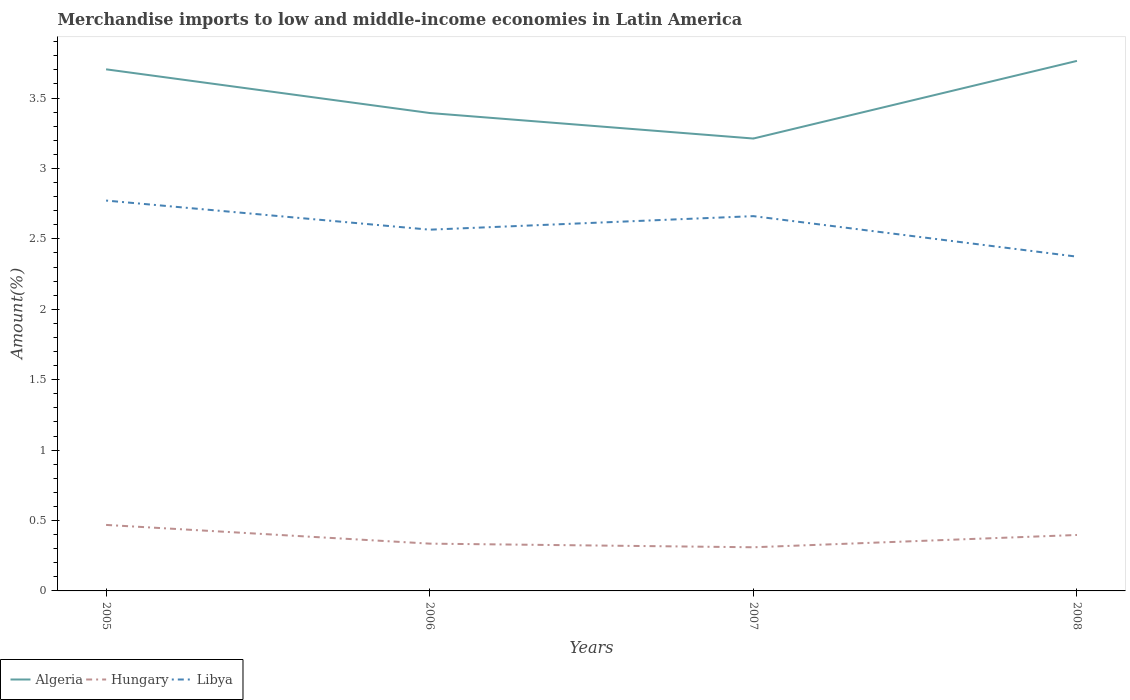How many different coloured lines are there?
Offer a terse response. 3. Is the number of lines equal to the number of legend labels?
Offer a very short reply. Yes. Across all years, what is the maximum percentage of amount earned from merchandise imports in Hungary?
Your answer should be very brief. 0.31. In which year was the percentage of amount earned from merchandise imports in Algeria maximum?
Provide a short and direct response. 2007. What is the total percentage of amount earned from merchandise imports in Libya in the graph?
Your answer should be compact. 0.19. What is the difference between the highest and the second highest percentage of amount earned from merchandise imports in Hungary?
Your answer should be compact. 0.16. What is the difference between the highest and the lowest percentage of amount earned from merchandise imports in Hungary?
Offer a very short reply. 2. Is the percentage of amount earned from merchandise imports in Algeria strictly greater than the percentage of amount earned from merchandise imports in Hungary over the years?
Your answer should be very brief. No. How many years are there in the graph?
Provide a short and direct response. 4. Are the values on the major ticks of Y-axis written in scientific E-notation?
Provide a short and direct response. No. Does the graph contain any zero values?
Offer a terse response. No. How many legend labels are there?
Your answer should be compact. 3. What is the title of the graph?
Provide a succinct answer. Merchandise imports to low and middle-income economies in Latin America. What is the label or title of the X-axis?
Keep it short and to the point. Years. What is the label or title of the Y-axis?
Your answer should be very brief. Amount(%). What is the Amount(%) of Algeria in 2005?
Your answer should be very brief. 3.7. What is the Amount(%) in Hungary in 2005?
Your answer should be compact. 0.47. What is the Amount(%) in Libya in 2005?
Your answer should be very brief. 2.77. What is the Amount(%) in Algeria in 2006?
Ensure brevity in your answer.  3.39. What is the Amount(%) in Hungary in 2006?
Give a very brief answer. 0.34. What is the Amount(%) of Libya in 2006?
Your answer should be very brief. 2.57. What is the Amount(%) of Algeria in 2007?
Offer a terse response. 3.21. What is the Amount(%) in Hungary in 2007?
Ensure brevity in your answer.  0.31. What is the Amount(%) of Libya in 2007?
Your answer should be compact. 2.66. What is the Amount(%) in Algeria in 2008?
Your answer should be very brief. 3.76. What is the Amount(%) in Hungary in 2008?
Provide a succinct answer. 0.4. What is the Amount(%) in Libya in 2008?
Your answer should be very brief. 2.37. Across all years, what is the maximum Amount(%) in Algeria?
Make the answer very short. 3.76. Across all years, what is the maximum Amount(%) of Hungary?
Ensure brevity in your answer.  0.47. Across all years, what is the maximum Amount(%) of Libya?
Make the answer very short. 2.77. Across all years, what is the minimum Amount(%) of Algeria?
Make the answer very short. 3.21. Across all years, what is the minimum Amount(%) of Hungary?
Make the answer very short. 0.31. Across all years, what is the minimum Amount(%) of Libya?
Your answer should be compact. 2.37. What is the total Amount(%) in Algeria in the graph?
Provide a succinct answer. 14.07. What is the total Amount(%) in Hungary in the graph?
Your response must be concise. 1.51. What is the total Amount(%) in Libya in the graph?
Ensure brevity in your answer.  10.37. What is the difference between the Amount(%) in Algeria in 2005 and that in 2006?
Your answer should be compact. 0.31. What is the difference between the Amount(%) in Hungary in 2005 and that in 2006?
Keep it short and to the point. 0.13. What is the difference between the Amount(%) of Libya in 2005 and that in 2006?
Give a very brief answer. 0.21. What is the difference between the Amount(%) of Algeria in 2005 and that in 2007?
Your response must be concise. 0.49. What is the difference between the Amount(%) of Hungary in 2005 and that in 2007?
Your response must be concise. 0.16. What is the difference between the Amount(%) in Libya in 2005 and that in 2007?
Your response must be concise. 0.11. What is the difference between the Amount(%) in Algeria in 2005 and that in 2008?
Provide a succinct answer. -0.06. What is the difference between the Amount(%) of Hungary in 2005 and that in 2008?
Ensure brevity in your answer.  0.07. What is the difference between the Amount(%) of Libya in 2005 and that in 2008?
Your answer should be very brief. 0.4. What is the difference between the Amount(%) of Algeria in 2006 and that in 2007?
Your answer should be very brief. 0.18. What is the difference between the Amount(%) in Hungary in 2006 and that in 2007?
Provide a short and direct response. 0.03. What is the difference between the Amount(%) in Libya in 2006 and that in 2007?
Make the answer very short. -0.1. What is the difference between the Amount(%) in Algeria in 2006 and that in 2008?
Offer a very short reply. -0.37. What is the difference between the Amount(%) of Hungary in 2006 and that in 2008?
Your response must be concise. -0.06. What is the difference between the Amount(%) of Libya in 2006 and that in 2008?
Make the answer very short. 0.19. What is the difference between the Amount(%) in Algeria in 2007 and that in 2008?
Ensure brevity in your answer.  -0.55. What is the difference between the Amount(%) in Hungary in 2007 and that in 2008?
Provide a short and direct response. -0.09. What is the difference between the Amount(%) in Libya in 2007 and that in 2008?
Ensure brevity in your answer.  0.29. What is the difference between the Amount(%) in Algeria in 2005 and the Amount(%) in Hungary in 2006?
Provide a short and direct response. 3.37. What is the difference between the Amount(%) in Algeria in 2005 and the Amount(%) in Libya in 2006?
Your response must be concise. 1.14. What is the difference between the Amount(%) of Hungary in 2005 and the Amount(%) of Libya in 2006?
Provide a succinct answer. -2.1. What is the difference between the Amount(%) in Algeria in 2005 and the Amount(%) in Hungary in 2007?
Provide a succinct answer. 3.39. What is the difference between the Amount(%) in Algeria in 2005 and the Amount(%) in Libya in 2007?
Keep it short and to the point. 1.04. What is the difference between the Amount(%) in Hungary in 2005 and the Amount(%) in Libya in 2007?
Your answer should be very brief. -2.19. What is the difference between the Amount(%) of Algeria in 2005 and the Amount(%) of Hungary in 2008?
Keep it short and to the point. 3.31. What is the difference between the Amount(%) in Algeria in 2005 and the Amount(%) in Libya in 2008?
Provide a succinct answer. 1.33. What is the difference between the Amount(%) of Hungary in 2005 and the Amount(%) of Libya in 2008?
Keep it short and to the point. -1.9. What is the difference between the Amount(%) of Algeria in 2006 and the Amount(%) of Hungary in 2007?
Give a very brief answer. 3.08. What is the difference between the Amount(%) in Algeria in 2006 and the Amount(%) in Libya in 2007?
Your answer should be very brief. 0.73. What is the difference between the Amount(%) in Hungary in 2006 and the Amount(%) in Libya in 2007?
Give a very brief answer. -2.33. What is the difference between the Amount(%) of Algeria in 2006 and the Amount(%) of Hungary in 2008?
Your response must be concise. 3. What is the difference between the Amount(%) in Hungary in 2006 and the Amount(%) in Libya in 2008?
Keep it short and to the point. -2.04. What is the difference between the Amount(%) of Algeria in 2007 and the Amount(%) of Hungary in 2008?
Make the answer very short. 2.81. What is the difference between the Amount(%) of Algeria in 2007 and the Amount(%) of Libya in 2008?
Your response must be concise. 0.84. What is the difference between the Amount(%) of Hungary in 2007 and the Amount(%) of Libya in 2008?
Provide a short and direct response. -2.06. What is the average Amount(%) in Algeria per year?
Ensure brevity in your answer.  3.52. What is the average Amount(%) in Hungary per year?
Offer a terse response. 0.38. What is the average Amount(%) in Libya per year?
Provide a succinct answer. 2.59. In the year 2005, what is the difference between the Amount(%) in Algeria and Amount(%) in Hungary?
Provide a short and direct response. 3.24. In the year 2005, what is the difference between the Amount(%) of Algeria and Amount(%) of Libya?
Offer a terse response. 0.93. In the year 2005, what is the difference between the Amount(%) of Hungary and Amount(%) of Libya?
Your answer should be compact. -2.3. In the year 2006, what is the difference between the Amount(%) of Algeria and Amount(%) of Hungary?
Ensure brevity in your answer.  3.06. In the year 2006, what is the difference between the Amount(%) in Algeria and Amount(%) in Libya?
Provide a short and direct response. 0.83. In the year 2006, what is the difference between the Amount(%) of Hungary and Amount(%) of Libya?
Your response must be concise. -2.23. In the year 2007, what is the difference between the Amount(%) in Algeria and Amount(%) in Hungary?
Ensure brevity in your answer.  2.9. In the year 2007, what is the difference between the Amount(%) in Algeria and Amount(%) in Libya?
Make the answer very short. 0.55. In the year 2007, what is the difference between the Amount(%) in Hungary and Amount(%) in Libya?
Keep it short and to the point. -2.35. In the year 2008, what is the difference between the Amount(%) of Algeria and Amount(%) of Hungary?
Provide a succinct answer. 3.37. In the year 2008, what is the difference between the Amount(%) in Algeria and Amount(%) in Libya?
Make the answer very short. 1.39. In the year 2008, what is the difference between the Amount(%) of Hungary and Amount(%) of Libya?
Provide a succinct answer. -1.98. What is the ratio of the Amount(%) of Algeria in 2005 to that in 2006?
Ensure brevity in your answer.  1.09. What is the ratio of the Amount(%) in Hungary in 2005 to that in 2006?
Provide a short and direct response. 1.4. What is the ratio of the Amount(%) of Libya in 2005 to that in 2006?
Ensure brevity in your answer.  1.08. What is the ratio of the Amount(%) in Algeria in 2005 to that in 2007?
Your response must be concise. 1.15. What is the ratio of the Amount(%) in Hungary in 2005 to that in 2007?
Make the answer very short. 1.51. What is the ratio of the Amount(%) in Libya in 2005 to that in 2007?
Your response must be concise. 1.04. What is the ratio of the Amount(%) in Algeria in 2005 to that in 2008?
Your answer should be very brief. 0.98. What is the ratio of the Amount(%) in Hungary in 2005 to that in 2008?
Give a very brief answer. 1.18. What is the ratio of the Amount(%) of Libya in 2005 to that in 2008?
Your answer should be very brief. 1.17. What is the ratio of the Amount(%) in Algeria in 2006 to that in 2007?
Your response must be concise. 1.06. What is the ratio of the Amount(%) of Hungary in 2006 to that in 2007?
Provide a short and direct response. 1.08. What is the ratio of the Amount(%) of Libya in 2006 to that in 2007?
Your response must be concise. 0.96. What is the ratio of the Amount(%) of Algeria in 2006 to that in 2008?
Provide a succinct answer. 0.9. What is the ratio of the Amount(%) of Hungary in 2006 to that in 2008?
Provide a short and direct response. 0.84. What is the ratio of the Amount(%) of Libya in 2006 to that in 2008?
Provide a short and direct response. 1.08. What is the ratio of the Amount(%) in Algeria in 2007 to that in 2008?
Your answer should be compact. 0.85. What is the ratio of the Amount(%) of Hungary in 2007 to that in 2008?
Provide a short and direct response. 0.78. What is the ratio of the Amount(%) in Libya in 2007 to that in 2008?
Keep it short and to the point. 1.12. What is the difference between the highest and the second highest Amount(%) in Algeria?
Provide a succinct answer. 0.06. What is the difference between the highest and the second highest Amount(%) of Hungary?
Offer a terse response. 0.07. What is the difference between the highest and the second highest Amount(%) in Libya?
Your response must be concise. 0.11. What is the difference between the highest and the lowest Amount(%) in Algeria?
Keep it short and to the point. 0.55. What is the difference between the highest and the lowest Amount(%) of Hungary?
Keep it short and to the point. 0.16. What is the difference between the highest and the lowest Amount(%) of Libya?
Provide a succinct answer. 0.4. 